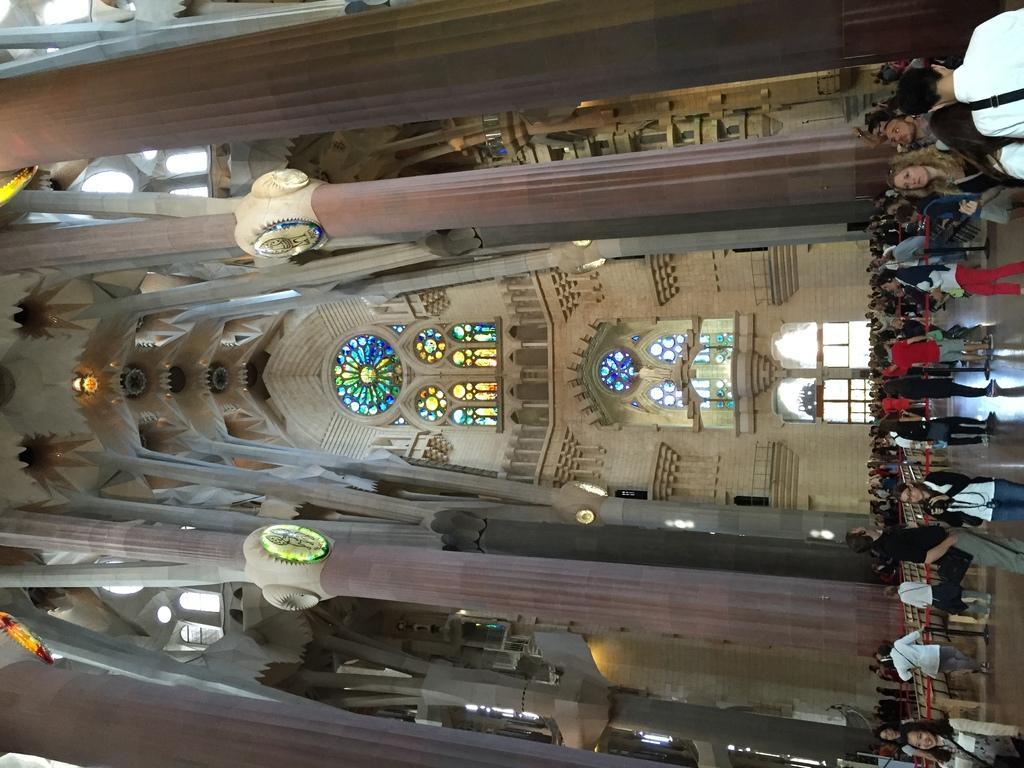Please provide a concise description of this image. In this image on the right there are many people. On the right there is a woman, she wears a jacket, trouser. This image is clicked inside a building. In the middle there are windows, pillows, roof and wall. 